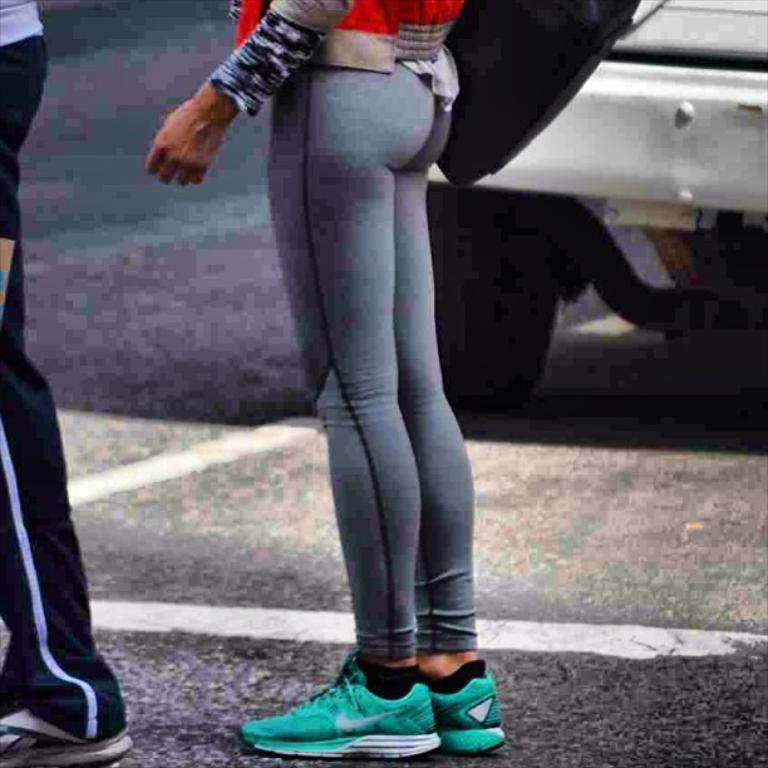In one or two sentences, can you explain what this image depicts? In this image there is road, there are persons truncated, there is a person truncated towards the left of the image, there is a vehicle on the road, there is a vehicle truncated towards the right of the image, there is an object truncated towards the top of the image. 